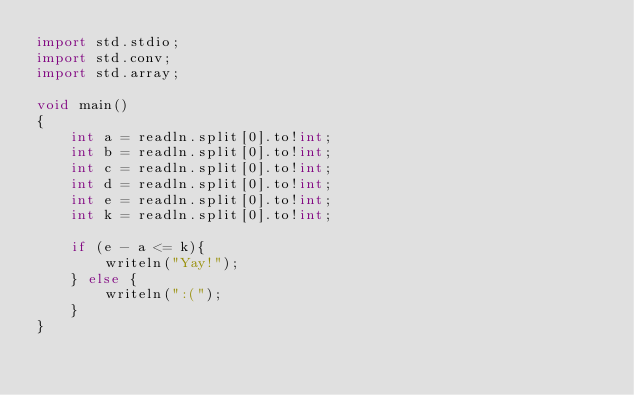<code> <loc_0><loc_0><loc_500><loc_500><_D_>import std.stdio;
import std.conv;
import std.array;

void main()
{
    int a = readln.split[0].to!int;
    int b = readln.split[0].to!int;
    int c = readln.split[0].to!int;
    int d = readln.split[0].to!int;
    int e = readln.split[0].to!int;
    int k = readln.split[0].to!int;

    if (e - a <= k){
        writeln("Yay!");
    } else {
        writeln(":(");
    }
}

</code> 